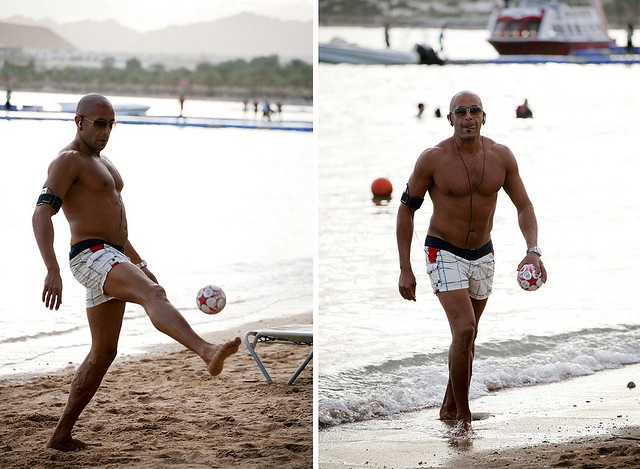Describe the objects in this image and their specific colors. I can see people in white, maroon, black, brown, and darkgray tones, people in white, maroon, black, and gray tones, boat in white, darkgray, black, and gray tones, chair in white, lightgray, gray, black, and darkgray tones, and boat in white, darkgray, gray, and lightgray tones in this image. 